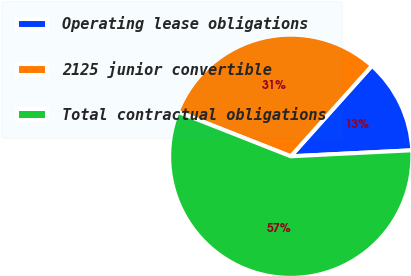Convert chart. <chart><loc_0><loc_0><loc_500><loc_500><pie_chart><fcel>Operating lease obligations<fcel>2125 junior convertible<fcel>Total contractual obligations<nl><fcel>12.58%<fcel>30.66%<fcel>56.76%<nl></chart> 